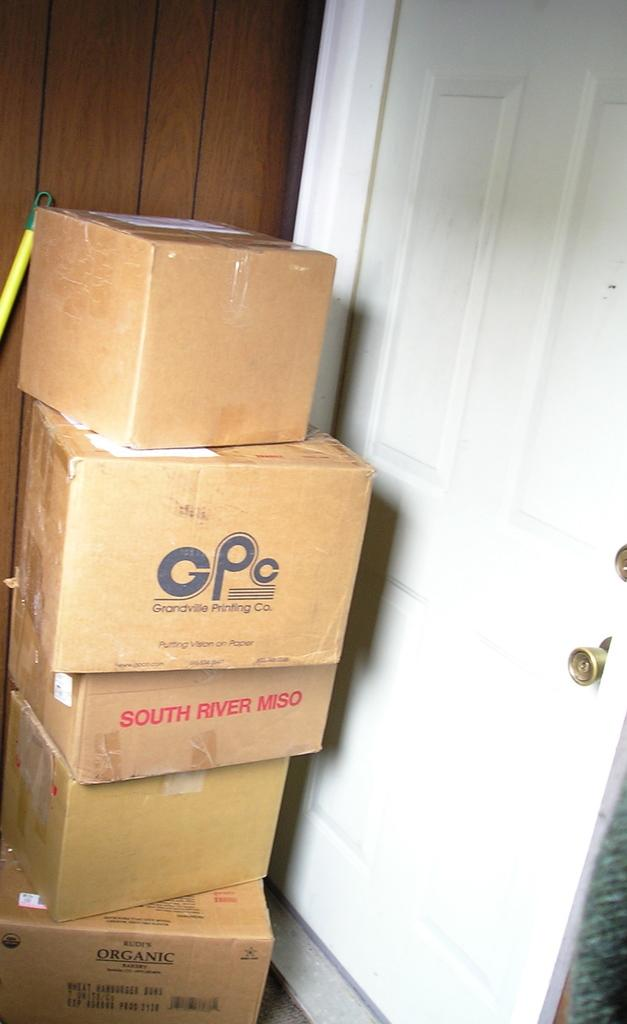<image>
Give a short and clear explanation of the subsequent image. Stacks of different boxes on top of each other in a doorway, text containing CPC, South River Miso, and Rudi's Orangic Bakery. 